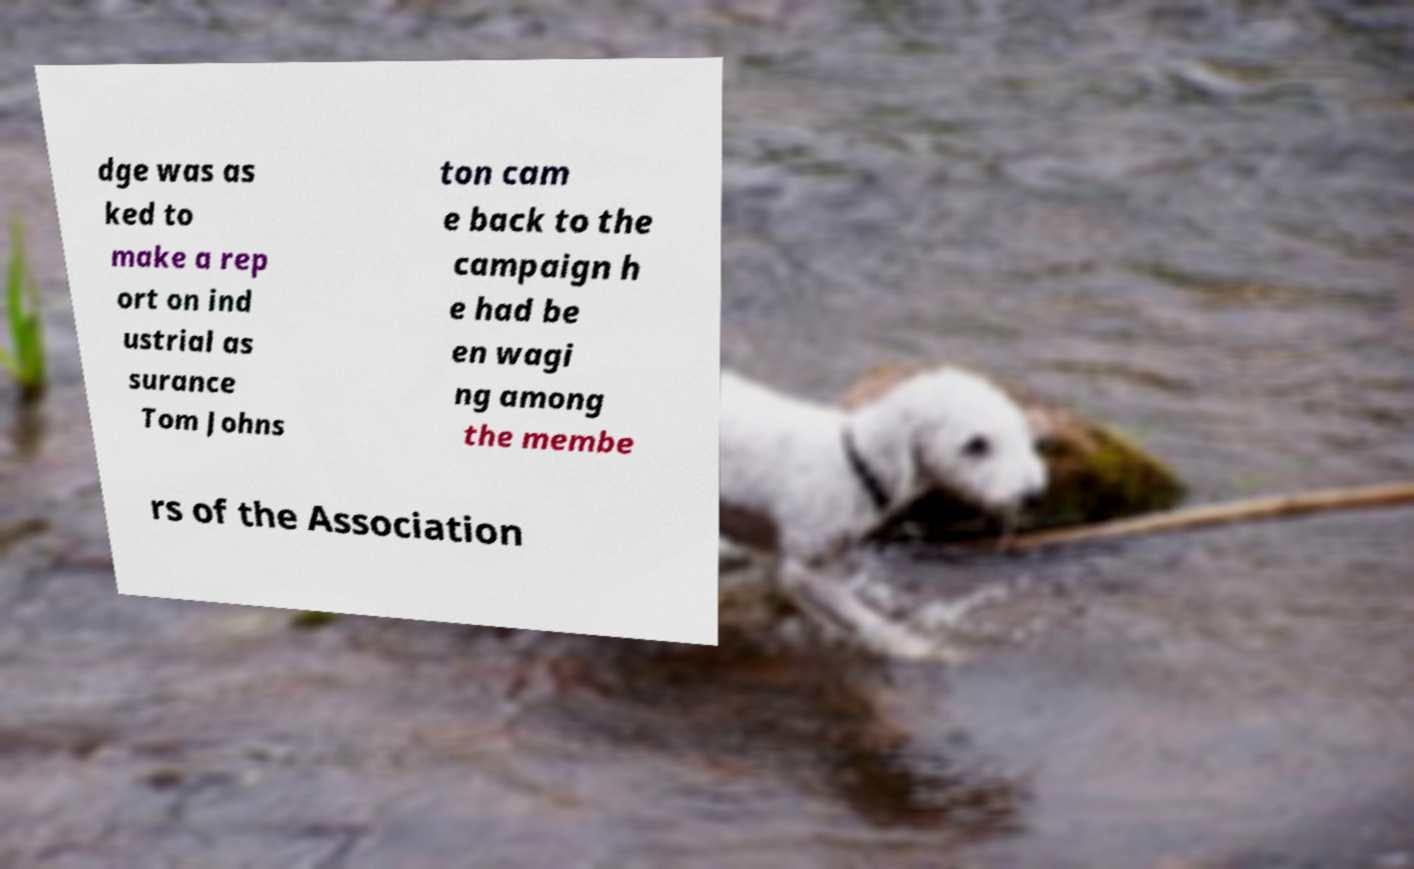Can you read and provide the text displayed in the image?This photo seems to have some interesting text. Can you extract and type it out for me? dge was as ked to make a rep ort on ind ustrial as surance Tom Johns ton cam e back to the campaign h e had be en wagi ng among the membe rs of the Association 